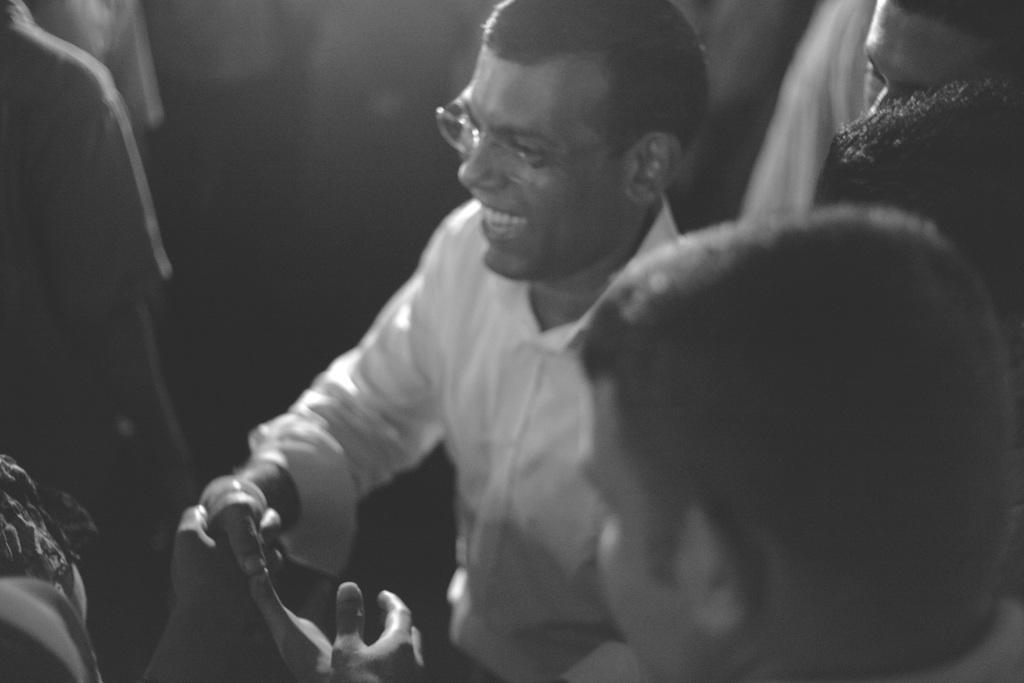What is happening between the people in the image? A man is shaking hands with another person in the image. How does the man shaking hands appear to feel? The man shaking hands has a smile on his face, indicating that he may be happy or pleased. Can you describe any physical characteristics of the man shaking hands? The man shaking hands is wearing spectacles. What type of border is visible around the man shaking hands in the image? There is no border visible around the man shaking hands in the image. How much debt does the man shaking hands have in the image? There is no information about the man's debt in the image. 